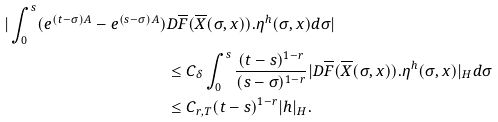Convert formula to latex. <formula><loc_0><loc_0><loc_500><loc_500>| \int _ { 0 } ^ { s } ( e ^ { ( t - \sigma ) A } - e ^ { ( s - \sigma ) A } ) & D \overline { F } ( \overline { X } ( \sigma , x ) ) . \eta ^ { h } ( \sigma , x ) d \sigma | \\ & \leq C _ { \delta } \int _ { 0 } ^ { s } \frac { ( t - s ) ^ { 1 - r } } { ( s - \sigma ) ^ { 1 - r } } | D \overline { F } ( \overline { X } ( \sigma , x ) ) . \eta ^ { h } ( \sigma , x ) | _ { H } d \sigma \\ & \leq C _ { r , T } ( t - s ) ^ { 1 - r } | h | _ { H } .</formula> 